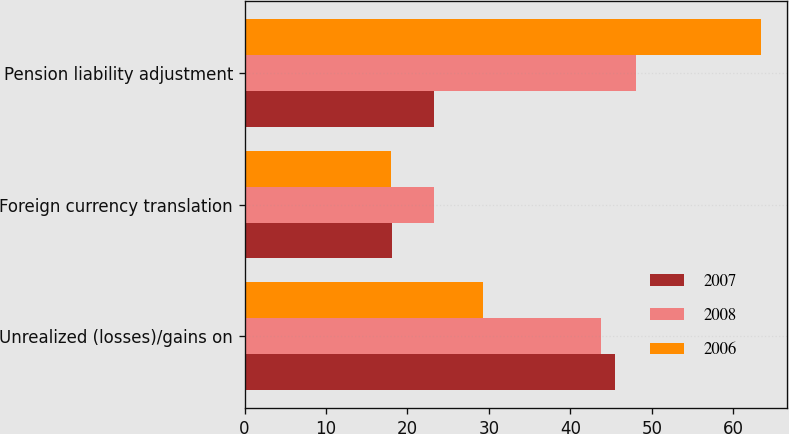Convert chart to OTSL. <chart><loc_0><loc_0><loc_500><loc_500><stacked_bar_chart><ecel><fcel>Unrealized (losses)/gains on<fcel>Foreign currency translation<fcel>Pension liability adjustment<nl><fcel>2007<fcel>45.5<fcel>18.1<fcel>23.3<nl><fcel>2008<fcel>43.7<fcel>23.3<fcel>48.1<nl><fcel>2006<fcel>29.3<fcel>18<fcel>63.4<nl></chart> 